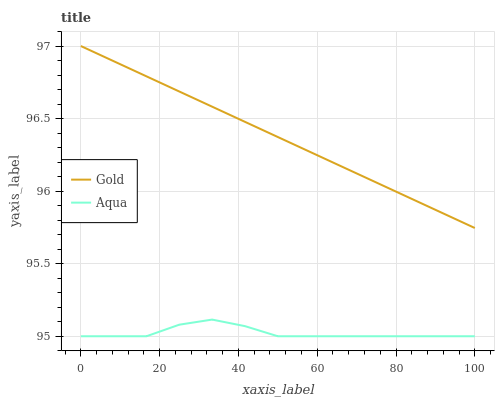Does Aqua have the minimum area under the curve?
Answer yes or no. Yes. Does Gold have the maximum area under the curve?
Answer yes or no. Yes. Does Gold have the minimum area under the curve?
Answer yes or no. No. Is Gold the smoothest?
Answer yes or no. Yes. Is Aqua the roughest?
Answer yes or no. Yes. Is Gold the roughest?
Answer yes or no. No. Does Aqua have the lowest value?
Answer yes or no. Yes. Does Gold have the lowest value?
Answer yes or no. No. Does Gold have the highest value?
Answer yes or no. Yes. Is Aqua less than Gold?
Answer yes or no. Yes. Is Gold greater than Aqua?
Answer yes or no. Yes. Does Aqua intersect Gold?
Answer yes or no. No. 